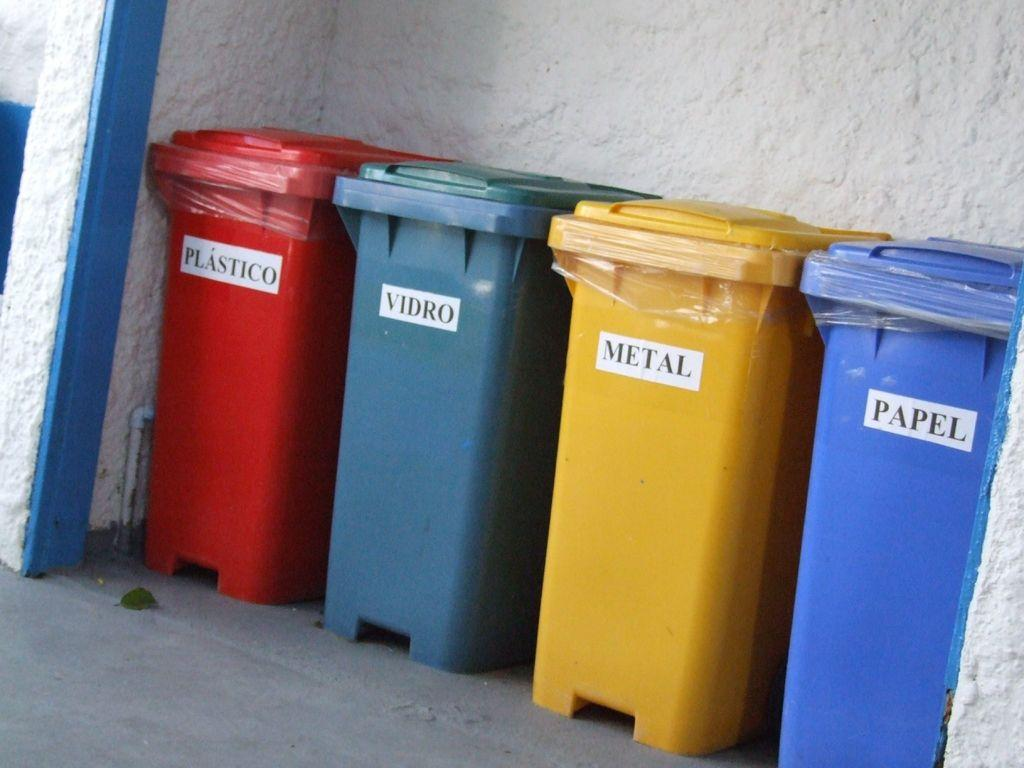<image>
Create a compact narrative representing the image presented. colorful garbage and recycling bins read Metal and Papel 